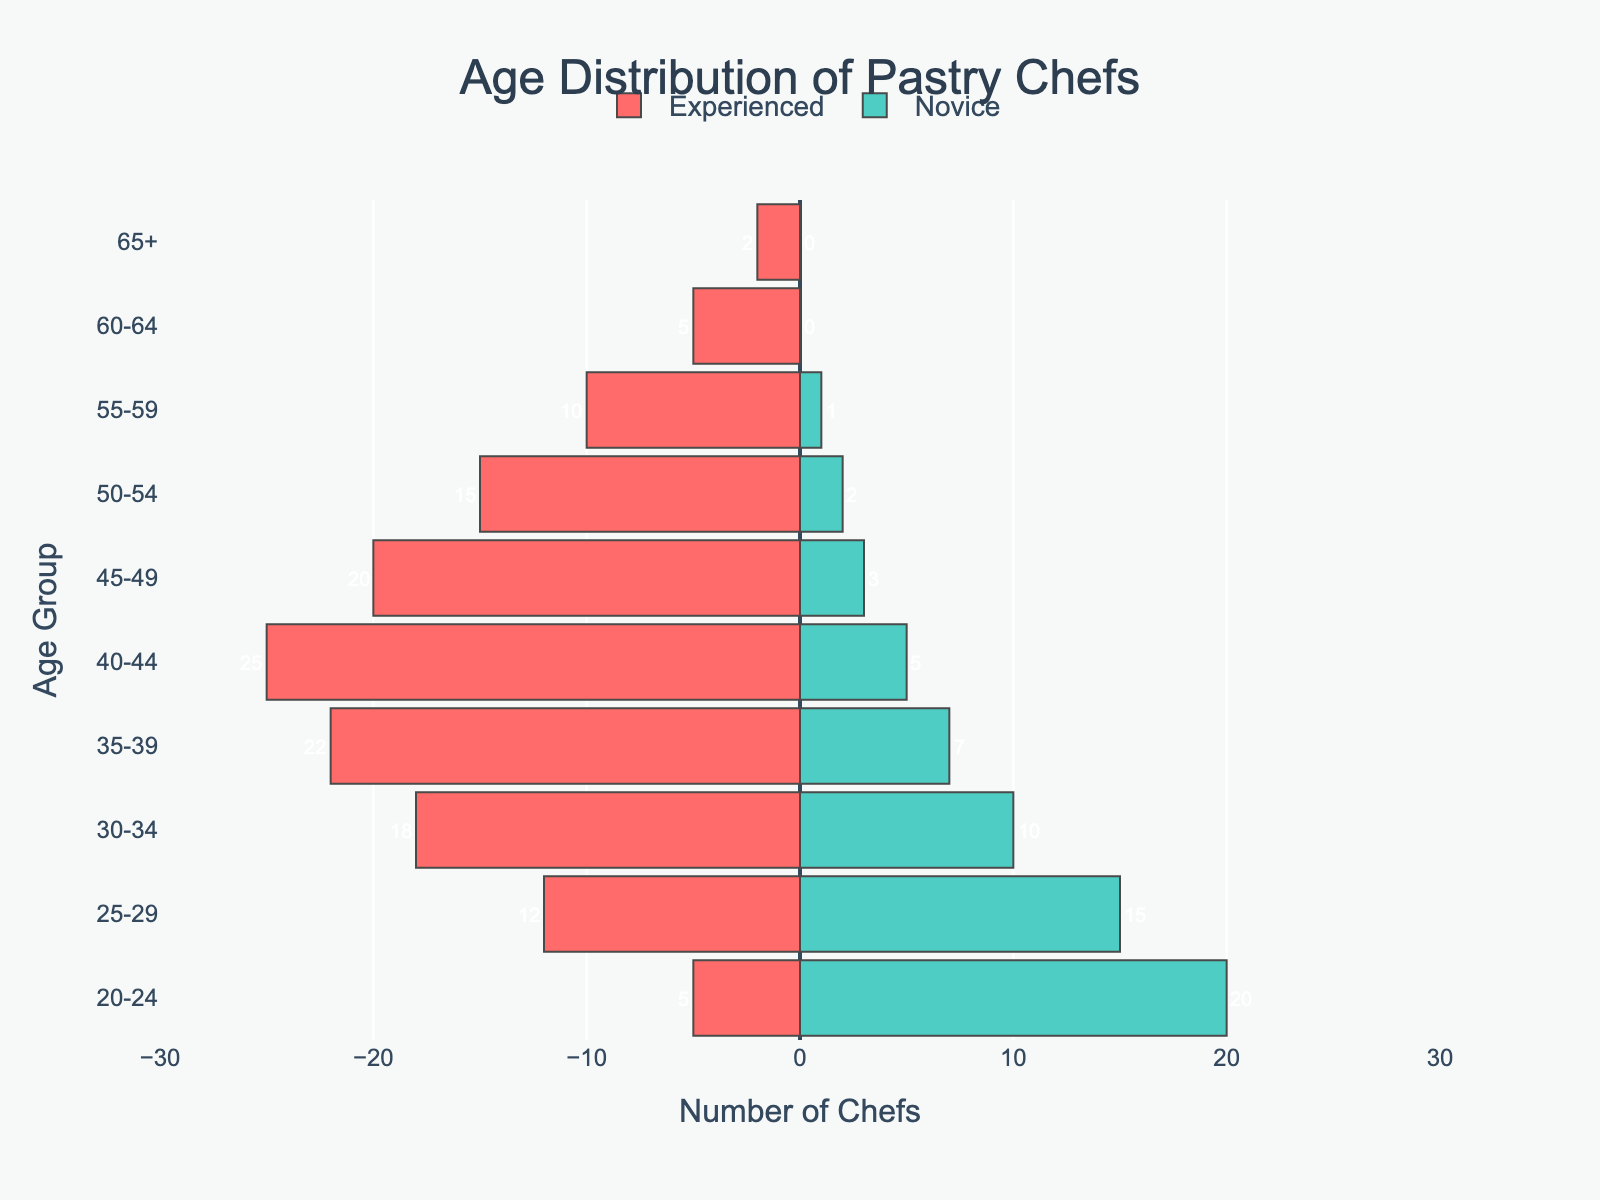What is the title of the figure? The title of the plot is prominently placed at the top center of the figure.
Answer: Age Distribution of Pastry Chefs What color represents experienced pastry chefs? By observing the plot, the bar segments for experienced chefs are visually marked in red.
Answer: Red How many novice pastry chefs are there in the age group 20-24? Look at the right side of the pyramid where novice chefs are represented and identify the value for the 20-24 age group.
Answer: 20 Which age group has the highest number of experienced pastry chefs? By comparing the height of the bars on the left side, the age group with the tallest bar on the experienced side will have the highest number.
Answer: 40-44 What is the total number of experienced pastry chefs? Sum the values of experienced chefs across all age groups: 5 + 12 + 18 + 22 + 25 + 20 + 15 + 10 + 5 + 2.
Answer: 134 What is the difference in the number of experienced and novice pastry chefs in the age group 30-34? Subtract the number of novice chefs from the experienced chefs in the age group 30-34: 18 - 10.
Answer: 8 What percentage of novice chefs are in the age group 25-29 compared to the total number of novice chefs? First, find the total number of novice chefs (20 + 15 + 10 + 7 + 5 + 3 + 2 + 1 + 0 + 0 = 63). Then, calculate the percentage for the 25-29 group: (15 / 63) * 100.
Answer: Approximately 23.81% Which age group has a closer balance between experienced and novice chefs? Compare the values for both groups across all age categories to find the smallest difference.
Answer: 25-29 What is the average number of novice pastry chefs across all age groups? Add up the number of novice chefs in all age groups and divide by the number of age groups: (20 + 15 + 10 + 7 + 5 + 3 + 2 + 1 + 0 + 0) / 10.
Answer: 6.3 In which age group is the disparity between experienced and novice pastry chefs the greatest? Examine the absolute differences between experienced and novice chefs across age groups and identify the largest value.
Answer: 40-44 